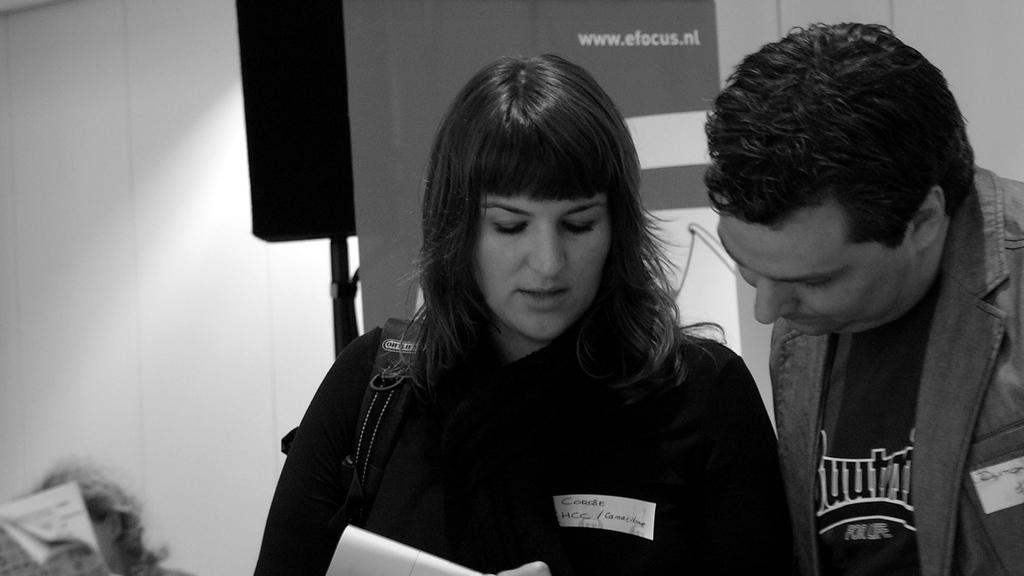<image>
Offer a succinct explanation of the picture presented. A man and a woman discussing something with website, www.efocus.nl shown behind them. 